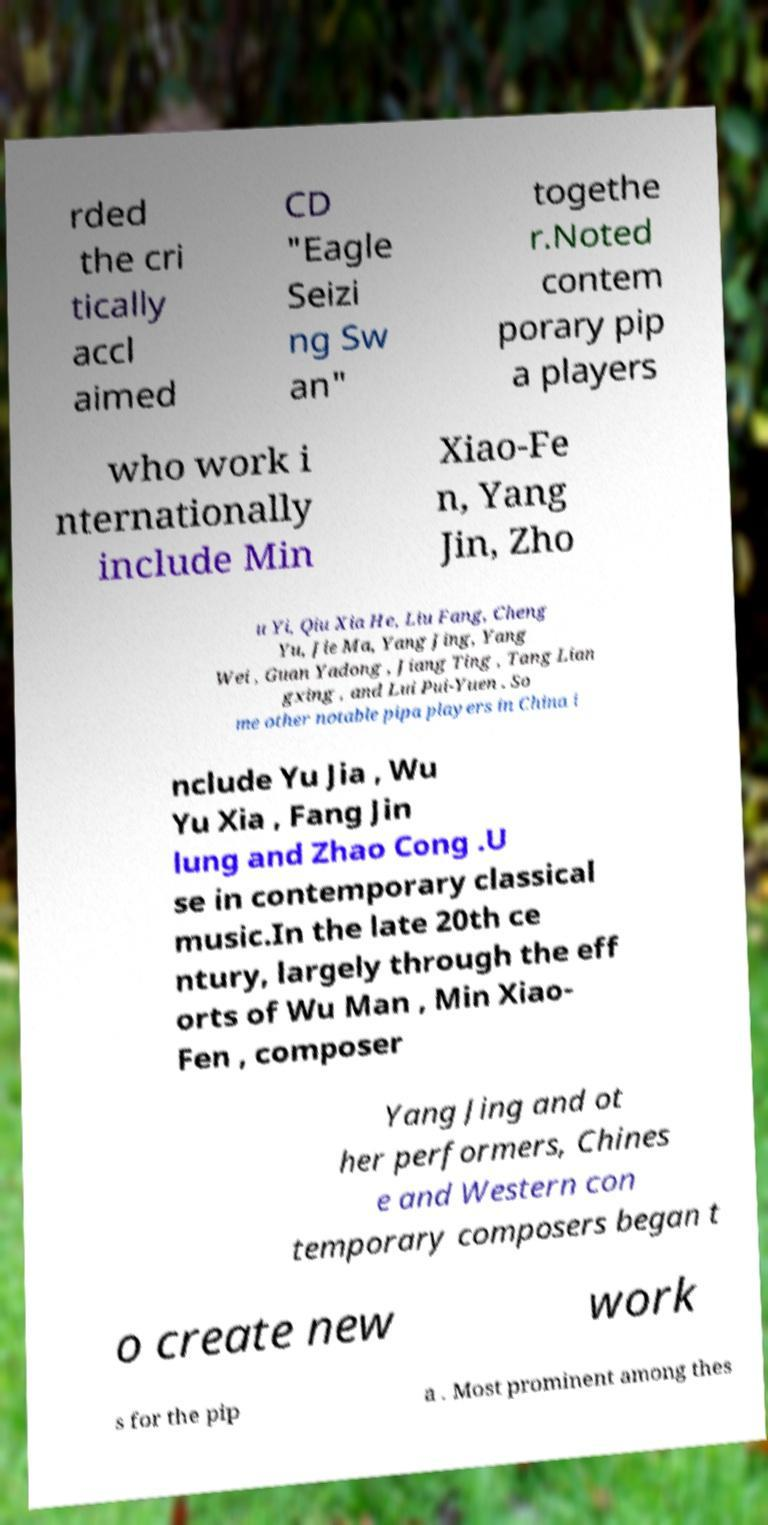For documentation purposes, I need the text within this image transcribed. Could you provide that? rded the cri tically accl aimed CD "Eagle Seizi ng Sw an" togethe r.Noted contem porary pip a players who work i nternationally include Min Xiao-Fe n, Yang Jin, Zho u Yi, Qiu Xia He, Liu Fang, Cheng Yu, Jie Ma, Yang Jing, Yang Wei , Guan Yadong , Jiang Ting , Tang Lian gxing , and Lui Pui-Yuen . So me other notable pipa players in China i nclude Yu Jia , Wu Yu Xia , Fang Jin lung and Zhao Cong .U se in contemporary classical music.In the late 20th ce ntury, largely through the eff orts of Wu Man , Min Xiao- Fen , composer Yang Jing and ot her performers, Chines e and Western con temporary composers began t o create new work s for the pip a . Most prominent among thes 